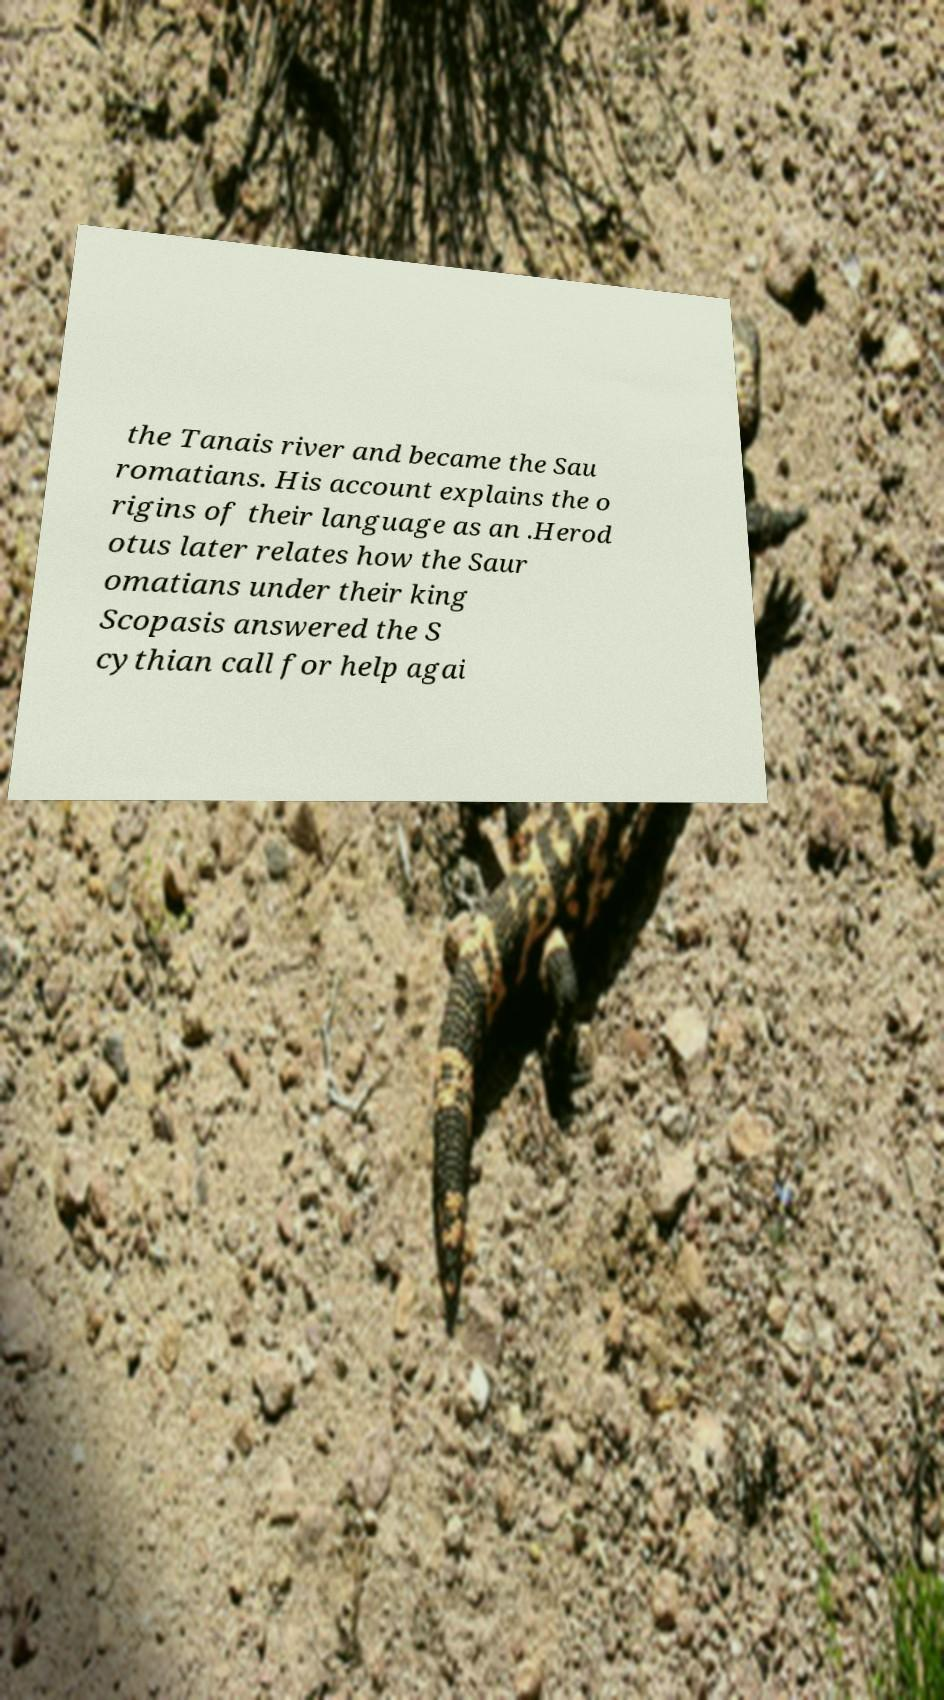There's text embedded in this image that I need extracted. Can you transcribe it verbatim? the Tanais river and became the Sau romatians. His account explains the o rigins of their language as an .Herod otus later relates how the Saur omatians under their king Scopasis answered the S cythian call for help agai 